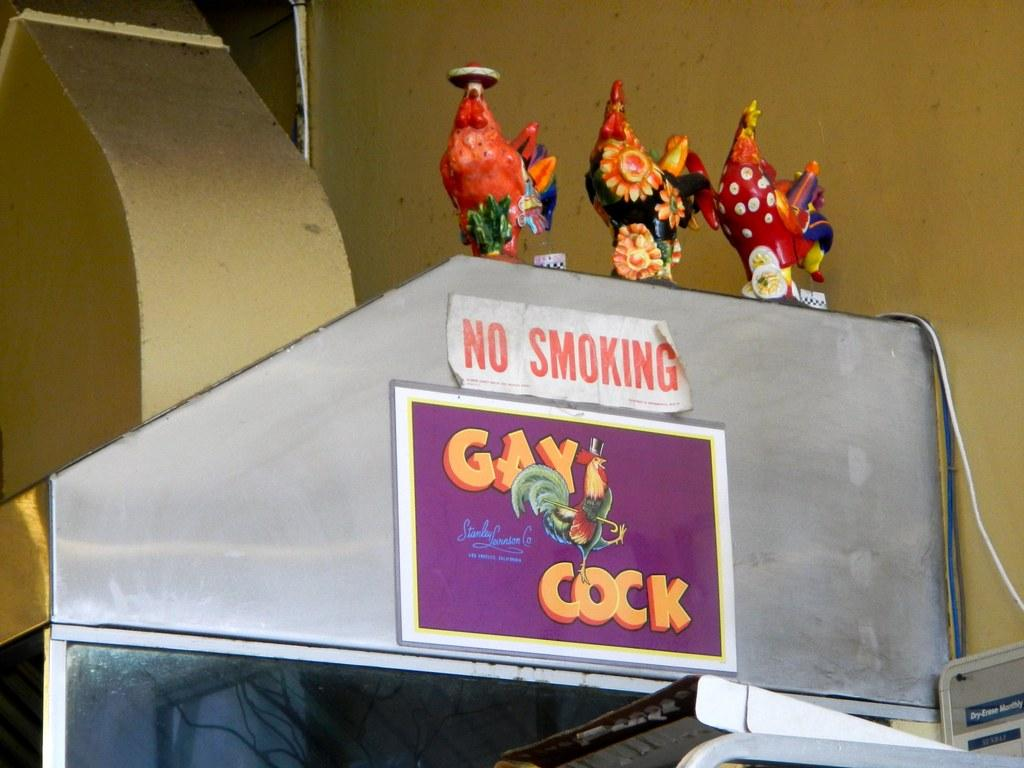What types of items can be seen in the image? There are show pieces in the image. Can you describe the arrangement of the objects in the image? There are objects on an object in the image. Where can we find additional objects in the image? There are objects visible in the bottom right of the image. What can be seen in the background of the image? A wire and a wall are visible in the background of the image. How does the cactus provide shade in the image? There is no cactus present in the image, so it cannot provide any shade. 